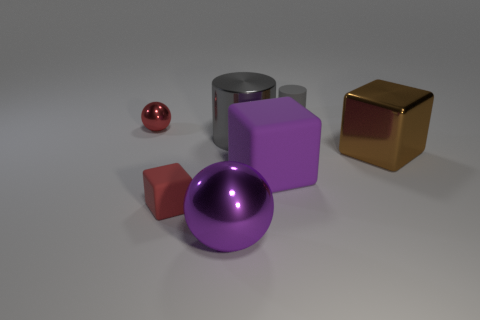Add 2 shiny balls. How many objects exist? 9 Subtract all blocks. How many objects are left? 4 Add 1 matte cylinders. How many matte cylinders are left? 2 Add 6 big shiny objects. How many big shiny objects exist? 9 Subtract 0 blue balls. How many objects are left? 7 Subtract all matte balls. Subtract all purple cubes. How many objects are left? 6 